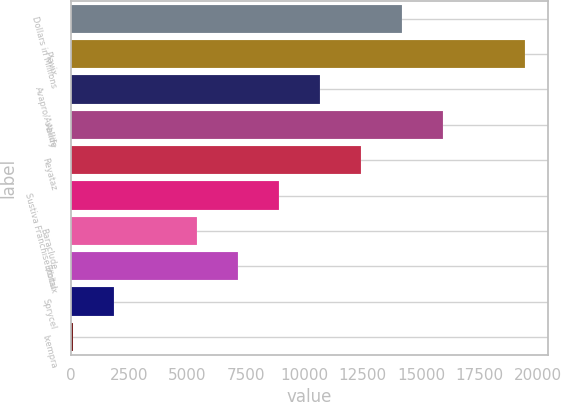Convert chart to OTSL. <chart><loc_0><loc_0><loc_500><loc_500><bar_chart><fcel>Dollars in Millions<fcel>Plavix<fcel>Avapro/Avalide<fcel>Abilify<fcel>Reyataz<fcel>Sustiva Franchise (total<fcel>Baraclude<fcel>Erbitux<fcel>Sprycel<fcel>Ixempra<nl><fcel>14192.2<fcel>19476.4<fcel>10669.4<fcel>15953.6<fcel>12430.8<fcel>8908<fcel>5385.2<fcel>7146.6<fcel>1862.4<fcel>101<nl></chart> 